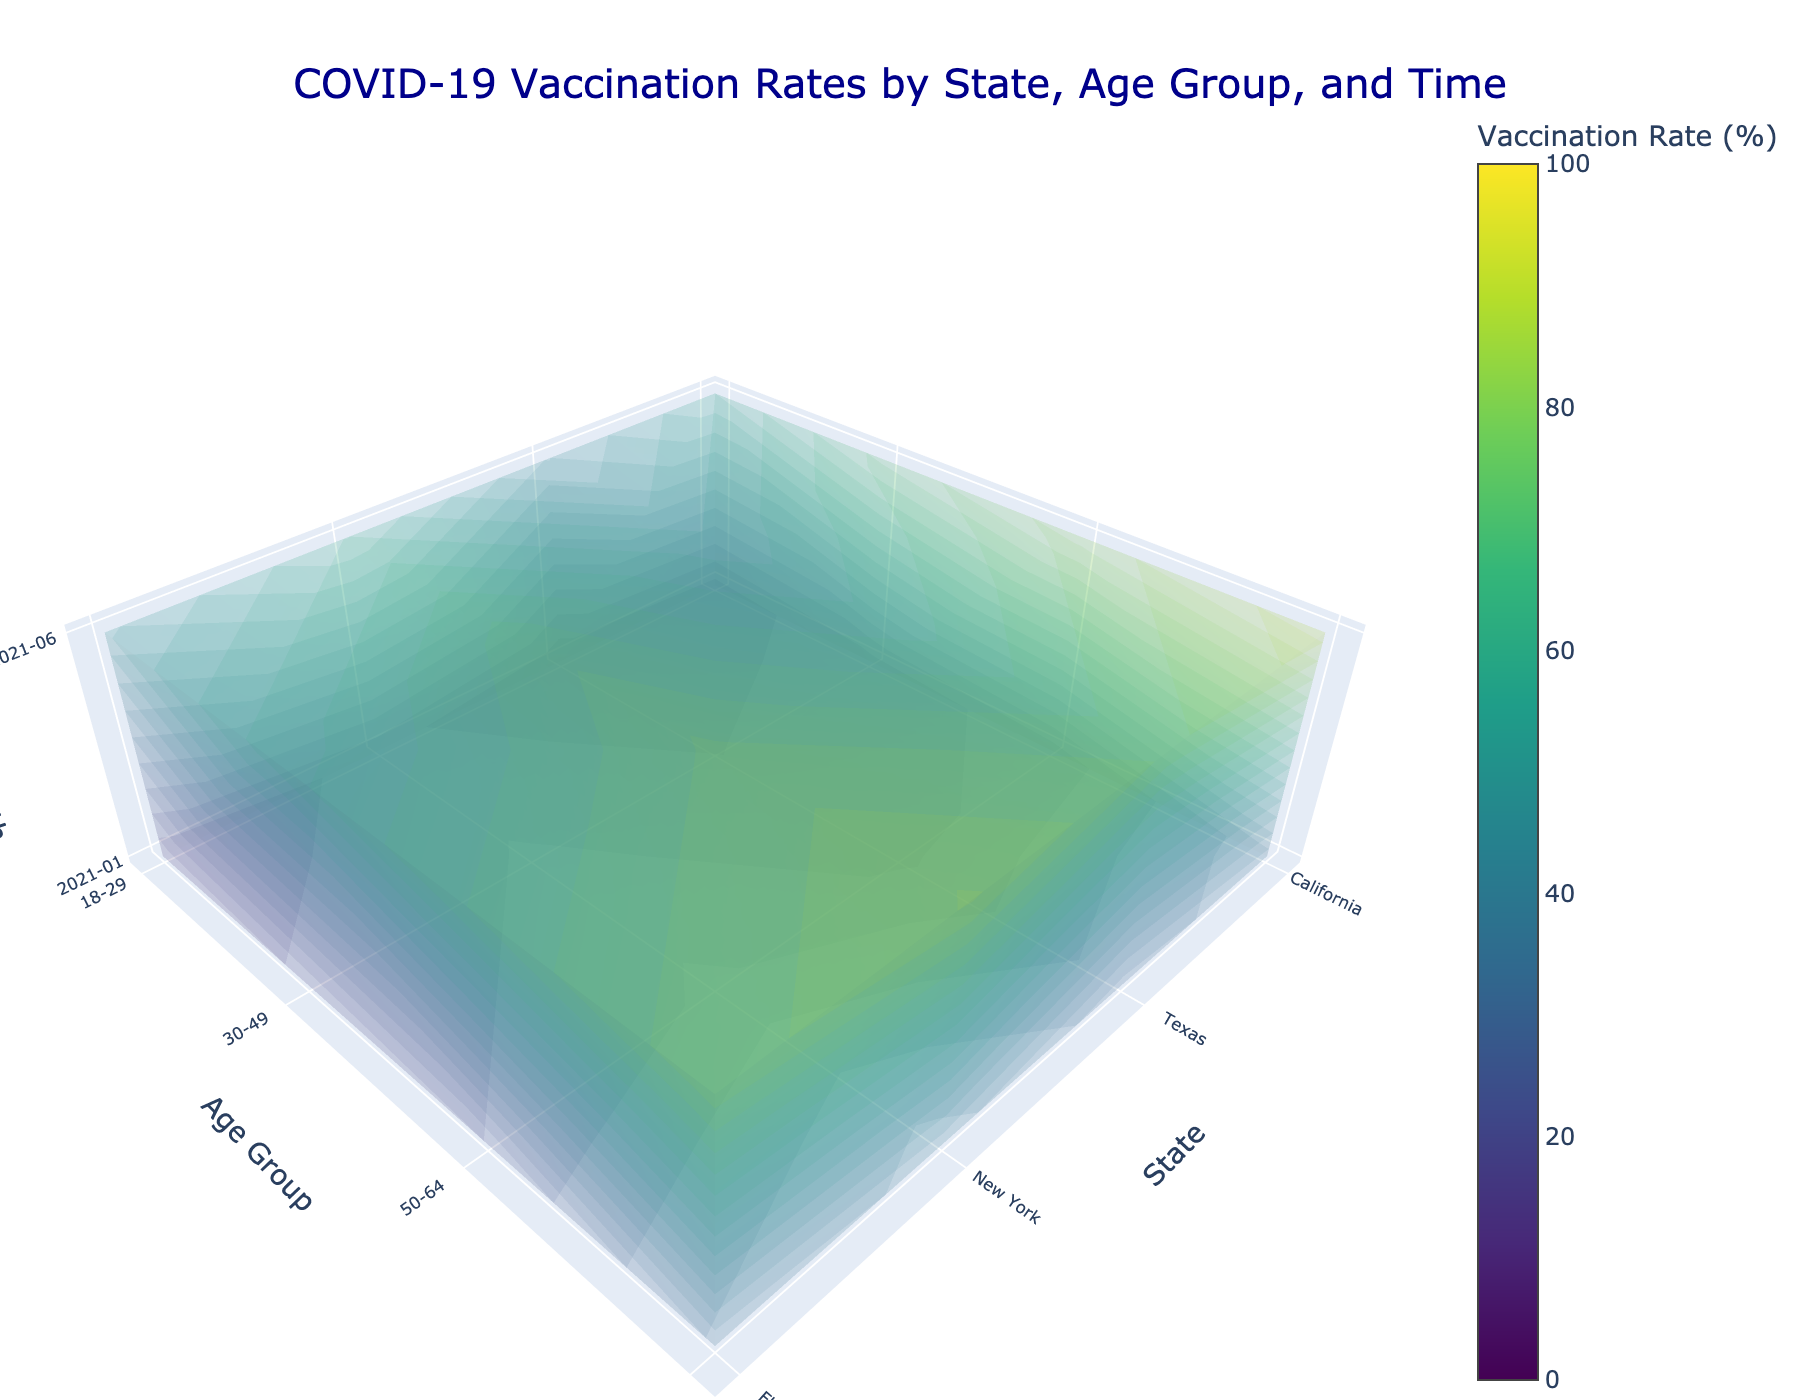What's the title of the figure? The title is located at the top center of the figure. It generally provides an overview of what the figure represents. In this case, it reads "COVID-19 Vaccination Rates by State, Age Group, and Time".
Answer: COVID-19 Vaccination Rates by State, Age Group, and Time How many states are represented in the figure? Look at the x-axis, which represents the states in the figure. The tick texts or labels will list all the states that are included. There are labels for California, Texas, New York, and Florida.
Answer: 4 Which age group in New York had the highest vaccination rate in June 2021? Identify the y-axis for the age groups and locate the section corresponding to New York on the x-axis. Then, find the z-axis for June 2021. Compare the values for each age group and select the highest one. The 65+ group has the highest value.
Answer: 65+ What's the average vaccination rate for the 18-29 age group in January 2021 across all states? Find the y-axis for the 18-29 age group and the z-axis for January 2021. Then, locate each state on the x-axis and note the vaccination rates: California (15.2), Texas (12.8), New York (17.9), Florida (13.5). Sum these and divide by the number of states: (15.2 + 12.8 + 17.9 + 13.5) / 4.
Answer: 14.85 Compare the vaccination rates between the 50-64 age group in Texas and the 65+ age group in California in June 2021. Which is higher? Locate the values on the y-axis corresponding to the 50-64 age group in Texas and the 65+ age group in California for June 2021 on the z-axis. The rates are 69.8 for Texas and 89.7 for California.
Answer: California (65+) Which month shows a higher overall vaccination rate for all the states combined, January 2021 or June 2021? Summarize the vaccination rates across all age groups and states for both months. January 2021 rates involve lower values overall, whereas June 2021 values are substantially higher. Summing the values confirms this.
Answer: June 2021 How does the vaccination rate of the 30-49 age group in Florida in June 2021 compare to that of the same age group in Texas in January 2021? Locate the Florida 30-49 age group data for June 2021 and Texas 30-49 age group data for January 2021. The values are 63.7 for Florida and 16.5 for Texas. Compare these two values.
Answer: Florida (June 2021) What percentage difference is there between the vaccination rate of the 65+ age group in New York and Texas in January 2021? Find the values for the 65+ age group in both New York (38.9) and Texas (31.2) for January 2021. Calculate the absolute difference (38.9 - 31.2) and then divide by the rate in Texas (31.2), multiply by 100 to get percentage: ((38.9 - 31.2) / 31.2) * 100.
Answer: 24.68% What is the general trend in vaccination rates from January 2021 to June 2021 across all age groups and states? Assess the overall direction of change from January 2021 to June 2021 by looking at the color intensity and values. Rates generally increase significantly for all age groups across all states from January to June.
Answer: Increase 